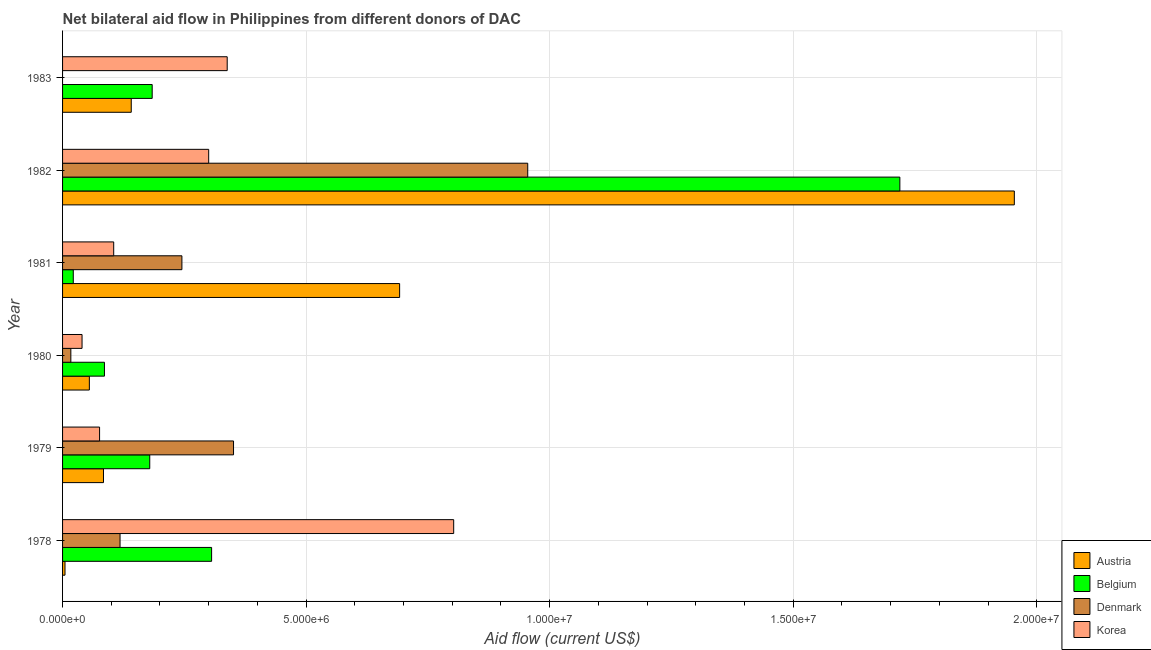How many different coloured bars are there?
Provide a succinct answer. 4. Are the number of bars per tick equal to the number of legend labels?
Offer a terse response. No. Are the number of bars on each tick of the Y-axis equal?
Provide a succinct answer. No. How many bars are there on the 1st tick from the bottom?
Your response must be concise. 4. What is the amount of aid given by korea in 1979?
Offer a terse response. 7.60e+05. Across all years, what is the maximum amount of aid given by austria?
Give a very brief answer. 1.95e+07. Across all years, what is the minimum amount of aid given by korea?
Offer a very short reply. 4.00e+05. In which year was the amount of aid given by austria maximum?
Provide a succinct answer. 1982. What is the total amount of aid given by austria in the graph?
Provide a short and direct response. 2.93e+07. What is the difference between the amount of aid given by belgium in 1978 and that in 1979?
Offer a very short reply. 1.27e+06. What is the difference between the amount of aid given by denmark in 1980 and the amount of aid given by korea in 1983?
Your answer should be compact. -3.21e+06. What is the average amount of aid given by denmark per year?
Your answer should be compact. 2.81e+06. In the year 1979, what is the difference between the amount of aid given by austria and amount of aid given by belgium?
Your answer should be very brief. -9.50e+05. In how many years, is the amount of aid given by denmark greater than 16000000 US$?
Give a very brief answer. 0. What is the ratio of the amount of aid given by korea in 1979 to that in 1980?
Offer a very short reply. 1.9. Is the amount of aid given by belgium in 1979 less than that in 1980?
Offer a terse response. No. Is the difference between the amount of aid given by belgium in 1978 and 1979 greater than the difference between the amount of aid given by denmark in 1978 and 1979?
Give a very brief answer. Yes. What is the difference between the highest and the second highest amount of aid given by belgium?
Provide a succinct answer. 1.41e+07. What is the difference between the highest and the lowest amount of aid given by belgium?
Provide a succinct answer. 1.70e+07. Are all the bars in the graph horizontal?
Provide a succinct answer. Yes. What is the difference between two consecutive major ticks on the X-axis?
Give a very brief answer. 5.00e+06. Are the values on the major ticks of X-axis written in scientific E-notation?
Provide a succinct answer. Yes. Where does the legend appear in the graph?
Give a very brief answer. Bottom right. How many legend labels are there?
Make the answer very short. 4. What is the title of the graph?
Offer a terse response. Net bilateral aid flow in Philippines from different donors of DAC. What is the label or title of the X-axis?
Your answer should be very brief. Aid flow (current US$). What is the Aid flow (current US$) of Belgium in 1978?
Provide a short and direct response. 3.06e+06. What is the Aid flow (current US$) in Denmark in 1978?
Provide a short and direct response. 1.18e+06. What is the Aid flow (current US$) of Korea in 1978?
Provide a short and direct response. 8.03e+06. What is the Aid flow (current US$) of Austria in 1979?
Your response must be concise. 8.40e+05. What is the Aid flow (current US$) in Belgium in 1979?
Offer a terse response. 1.79e+06. What is the Aid flow (current US$) of Denmark in 1979?
Provide a succinct answer. 3.51e+06. What is the Aid flow (current US$) of Korea in 1979?
Your response must be concise. 7.60e+05. What is the Aid flow (current US$) of Belgium in 1980?
Make the answer very short. 8.60e+05. What is the Aid flow (current US$) of Austria in 1981?
Provide a succinct answer. 6.92e+06. What is the Aid flow (current US$) in Belgium in 1981?
Your response must be concise. 2.20e+05. What is the Aid flow (current US$) of Denmark in 1981?
Provide a short and direct response. 2.45e+06. What is the Aid flow (current US$) in Korea in 1981?
Offer a very short reply. 1.05e+06. What is the Aid flow (current US$) of Austria in 1982?
Provide a short and direct response. 1.95e+07. What is the Aid flow (current US$) in Belgium in 1982?
Offer a very short reply. 1.72e+07. What is the Aid flow (current US$) in Denmark in 1982?
Provide a succinct answer. 9.55e+06. What is the Aid flow (current US$) of Austria in 1983?
Your answer should be very brief. 1.41e+06. What is the Aid flow (current US$) of Belgium in 1983?
Your answer should be compact. 1.84e+06. What is the Aid flow (current US$) of Korea in 1983?
Your answer should be compact. 3.38e+06. Across all years, what is the maximum Aid flow (current US$) in Austria?
Your response must be concise. 1.95e+07. Across all years, what is the maximum Aid flow (current US$) of Belgium?
Give a very brief answer. 1.72e+07. Across all years, what is the maximum Aid flow (current US$) in Denmark?
Make the answer very short. 9.55e+06. Across all years, what is the maximum Aid flow (current US$) of Korea?
Give a very brief answer. 8.03e+06. Across all years, what is the minimum Aid flow (current US$) in Austria?
Make the answer very short. 5.00e+04. Across all years, what is the minimum Aid flow (current US$) of Korea?
Your answer should be compact. 4.00e+05. What is the total Aid flow (current US$) of Austria in the graph?
Provide a short and direct response. 2.93e+07. What is the total Aid flow (current US$) of Belgium in the graph?
Keep it short and to the point. 2.50e+07. What is the total Aid flow (current US$) of Denmark in the graph?
Keep it short and to the point. 1.69e+07. What is the total Aid flow (current US$) in Korea in the graph?
Keep it short and to the point. 1.66e+07. What is the difference between the Aid flow (current US$) in Austria in 1978 and that in 1979?
Provide a succinct answer. -7.90e+05. What is the difference between the Aid flow (current US$) of Belgium in 1978 and that in 1979?
Ensure brevity in your answer.  1.27e+06. What is the difference between the Aid flow (current US$) in Denmark in 1978 and that in 1979?
Provide a short and direct response. -2.33e+06. What is the difference between the Aid flow (current US$) of Korea in 1978 and that in 1979?
Provide a short and direct response. 7.27e+06. What is the difference between the Aid flow (current US$) of Austria in 1978 and that in 1980?
Offer a terse response. -5.00e+05. What is the difference between the Aid flow (current US$) in Belgium in 1978 and that in 1980?
Offer a very short reply. 2.20e+06. What is the difference between the Aid flow (current US$) of Denmark in 1978 and that in 1980?
Keep it short and to the point. 1.01e+06. What is the difference between the Aid flow (current US$) in Korea in 1978 and that in 1980?
Provide a short and direct response. 7.63e+06. What is the difference between the Aid flow (current US$) in Austria in 1978 and that in 1981?
Your response must be concise. -6.87e+06. What is the difference between the Aid flow (current US$) of Belgium in 1978 and that in 1981?
Your response must be concise. 2.84e+06. What is the difference between the Aid flow (current US$) of Denmark in 1978 and that in 1981?
Offer a very short reply. -1.27e+06. What is the difference between the Aid flow (current US$) in Korea in 1978 and that in 1981?
Keep it short and to the point. 6.98e+06. What is the difference between the Aid flow (current US$) of Austria in 1978 and that in 1982?
Make the answer very short. -1.95e+07. What is the difference between the Aid flow (current US$) of Belgium in 1978 and that in 1982?
Give a very brief answer. -1.41e+07. What is the difference between the Aid flow (current US$) of Denmark in 1978 and that in 1982?
Offer a very short reply. -8.37e+06. What is the difference between the Aid flow (current US$) in Korea in 1978 and that in 1982?
Ensure brevity in your answer.  5.03e+06. What is the difference between the Aid flow (current US$) in Austria in 1978 and that in 1983?
Your answer should be very brief. -1.36e+06. What is the difference between the Aid flow (current US$) of Belgium in 1978 and that in 1983?
Ensure brevity in your answer.  1.22e+06. What is the difference between the Aid flow (current US$) in Korea in 1978 and that in 1983?
Offer a very short reply. 4.65e+06. What is the difference between the Aid flow (current US$) in Austria in 1979 and that in 1980?
Offer a terse response. 2.90e+05. What is the difference between the Aid flow (current US$) of Belgium in 1979 and that in 1980?
Offer a terse response. 9.30e+05. What is the difference between the Aid flow (current US$) in Denmark in 1979 and that in 1980?
Keep it short and to the point. 3.34e+06. What is the difference between the Aid flow (current US$) in Korea in 1979 and that in 1980?
Your answer should be compact. 3.60e+05. What is the difference between the Aid flow (current US$) of Austria in 1979 and that in 1981?
Your answer should be very brief. -6.08e+06. What is the difference between the Aid flow (current US$) in Belgium in 1979 and that in 1981?
Offer a very short reply. 1.57e+06. What is the difference between the Aid flow (current US$) of Denmark in 1979 and that in 1981?
Keep it short and to the point. 1.06e+06. What is the difference between the Aid flow (current US$) in Korea in 1979 and that in 1981?
Ensure brevity in your answer.  -2.90e+05. What is the difference between the Aid flow (current US$) of Austria in 1979 and that in 1982?
Offer a terse response. -1.87e+07. What is the difference between the Aid flow (current US$) in Belgium in 1979 and that in 1982?
Make the answer very short. -1.54e+07. What is the difference between the Aid flow (current US$) of Denmark in 1979 and that in 1982?
Offer a terse response. -6.04e+06. What is the difference between the Aid flow (current US$) in Korea in 1979 and that in 1982?
Offer a terse response. -2.24e+06. What is the difference between the Aid flow (current US$) in Austria in 1979 and that in 1983?
Your answer should be very brief. -5.70e+05. What is the difference between the Aid flow (current US$) in Belgium in 1979 and that in 1983?
Your response must be concise. -5.00e+04. What is the difference between the Aid flow (current US$) in Korea in 1979 and that in 1983?
Give a very brief answer. -2.62e+06. What is the difference between the Aid flow (current US$) in Austria in 1980 and that in 1981?
Your answer should be very brief. -6.37e+06. What is the difference between the Aid flow (current US$) in Belgium in 1980 and that in 1981?
Offer a terse response. 6.40e+05. What is the difference between the Aid flow (current US$) in Denmark in 1980 and that in 1981?
Keep it short and to the point. -2.28e+06. What is the difference between the Aid flow (current US$) in Korea in 1980 and that in 1981?
Provide a short and direct response. -6.50e+05. What is the difference between the Aid flow (current US$) in Austria in 1980 and that in 1982?
Provide a succinct answer. -1.90e+07. What is the difference between the Aid flow (current US$) in Belgium in 1980 and that in 1982?
Ensure brevity in your answer.  -1.63e+07. What is the difference between the Aid flow (current US$) of Denmark in 1980 and that in 1982?
Ensure brevity in your answer.  -9.38e+06. What is the difference between the Aid flow (current US$) of Korea in 1980 and that in 1982?
Your answer should be very brief. -2.60e+06. What is the difference between the Aid flow (current US$) of Austria in 1980 and that in 1983?
Your answer should be compact. -8.60e+05. What is the difference between the Aid flow (current US$) of Belgium in 1980 and that in 1983?
Offer a very short reply. -9.80e+05. What is the difference between the Aid flow (current US$) in Korea in 1980 and that in 1983?
Your response must be concise. -2.98e+06. What is the difference between the Aid flow (current US$) of Austria in 1981 and that in 1982?
Your response must be concise. -1.26e+07. What is the difference between the Aid flow (current US$) in Belgium in 1981 and that in 1982?
Your answer should be very brief. -1.70e+07. What is the difference between the Aid flow (current US$) in Denmark in 1981 and that in 1982?
Keep it short and to the point. -7.10e+06. What is the difference between the Aid flow (current US$) of Korea in 1981 and that in 1982?
Provide a short and direct response. -1.95e+06. What is the difference between the Aid flow (current US$) of Austria in 1981 and that in 1983?
Provide a short and direct response. 5.51e+06. What is the difference between the Aid flow (current US$) in Belgium in 1981 and that in 1983?
Ensure brevity in your answer.  -1.62e+06. What is the difference between the Aid flow (current US$) of Korea in 1981 and that in 1983?
Offer a very short reply. -2.33e+06. What is the difference between the Aid flow (current US$) in Austria in 1982 and that in 1983?
Offer a very short reply. 1.81e+07. What is the difference between the Aid flow (current US$) in Belgium in 1982 and that in 1983?
Make the answer very short. 1.54e+07. What is the difference between the Aid flow (current US$) in Korea in 1982 and that in 1983?
Give a very brief answer. -3.80e+05. What is the difference between the Aid flow (current US$) in Austria in 1978 and the Aid flow (current US$) in Belgium in 1979?
Ensure brevity in your answer.  -1.74e+06. What is the difference between the Aid flow (current US$) of Austria in 1978 and the Aid flow (current US$) of Denmark in 1979?
Your answer should be compact. -3.46e+06. What is the difference between the Aid flow (current US$) of Austria in 1978 and the Aid flow (current US$) of Korea in 1979?
Keep it short and to the point. -7.10e+05. What is the difference between the Aid flow (current US$) in Belgium in 1978 and the Aid flow (current US$) in Denmark in 1979?
Keep it short and to the point. -4.50e+05. What is the difference between the Aid flow (current US$) in Belgium in 1978 and the Aid flow (current US$) in Korea in 1979?
Your answer should be compact. 2.30e+06. What is the difference between the Aid flow (current US$) in Denmark in 1978 and the Aid flow (current US$) in Korea in 1979?
Keep it short and to the point. 4.20e+05. What is the difference between the Aid flow (current US$) in Austria in 1978 and the Aid flow (current US$) in Belgium in 1980?
Provide a succinct answer. -8.10e+05. What is the difference between the Aid flow (current US$) in Austria in 1978 and the Aid flow (current US$) in Denmark in 1980?
Ensure brevity in your answer.  -1.20e+05. What is the difference between the Aid flow (current US$) of Austria in 1978 and the Aid flow (current US$) of Korea in 1980?
Give a very brief answer. -3.50e+05. What is the difference between the Aid flow (current US$) in Belgium in 1978 and the Aid flow (current US$) in Denmark in 1980?
Provide a short and direct response. 2.89e+06. What is the difference between the Aid flow (current US$) in Belgium in 1978 and the Aid flow (current US$) in Korea in 1980?
Keep it short and to the point. 2.66e+06. What is the difference between the Aid flow (current US$) of Denmark in 1978 and the Aid flow (current US$) of Korea in 1980?
Provide a short and direct response. 7.80e+05. What is the difference between the Aid flow (current US$) in Austria in 1978 and the Aid flow (current US$) in Denmark in 1981?
Offer a very short reply. -2.40e+06. What is the difference between the Aid flow (current US$) in Austria in 1978 and the Aid flow (current US$) in Korea in 1981?
Offer a very short reply. -1.00e+06. What is the difference between the Aid flow (current US$) in Belgium in 1978 and the Aid flow (current US$) in Korea in 1981?
Offer a terse response. 2.01e+06. What is the difference between the Aid flow (current US$) in Austria in 1978 and the Aid flow (current US$) in Belgium in 1982?
Your answer should be compact. -1.71e+07. What is the difference between the Aid flow (current US$) in Austria in 1978 and the Aid flow (current US$) in Denmark in 1982?
Provide a succinct answer. -9.50e+06. What is the difference between the Aid flow (current US$) of Austria in 1978 and the Aid flow (current US$) of Korea in 1982?
Ensure brevity in your answer.  -2.95e+06. What is the difference between the Aid flow (current US$) in Belgium in 1978 and the Aid flow (current US$) in Denmark in 1982?
Offer a terse response. -6.49e+06. What is the difference between the Aid flow (current US$) of Denmark in 1978 and the Aid flow (current US$) of Korea in 1982?
Provide a short and direct response. -1.82e+06. What is the difference between the Aid flow (current US$) of Austria in 1978 and the Aid flow (current US$) of Belgium in 1983?
Your answer should be compact. -1.79e+06. What is the difference between the Aid flow (current US$) of Austria in 1978 and the Aid flow (current US$) of Korea in 1983?
Ensure brevity in your answer.  -3.33e+06. What is the difference between the Aid flow (current US$) of Belgium in 1978 and the Aid flow (current US$) of Korea in 1983?
Ensure brevity in your answer.  -3.20e+05. What is the difference between the Aid flow (current US$) of Denmark in 1978 and the Aid flow (current US$) of Korea in 1983?
Your answer should be very brief. -2.20e+06. What is the difference between the Aid flow (current US$) in Austria in 1979 and the Aid flow (current US$) in Denmark in 1980?
Your answer should be compact. 6.70e+05. What is the difference between the Aid flow (current US$) of Austria in 1979 and the Aid flow (current US$) of Korea in 1980?
Keep it short and to the point. 4.40e+05. What is the difference between the Aid flow (current US$) of Belgium in 1979 and the Aid flow (current US$) of Denmark in 1980?
Your answer should be very brief. 1.62e+06. What is the difference between the Aid flow (current US$) of Belgium in 1979 and the Aid flow (current US$) of Korea in 1980?
Keep it short and to the point. 1.39e+06. What is the difference between the Aid flow (current US$) of Denmark in 1979 and the Aid flow (current US$) of Korea in 1980?
Offer a terse response. 3.11e+06. What is the difference between the Aid flow (current US$) in Austria in 1979 and the Aid flow (current US$) in Belgium in 1981?
Provide a short and direct response. 6.20e+05. What is the difference between the Aid flow (current US$) of Austria in 1979 and the Aid flow (current US$) of Denmark in 1981?
Provide a succinct answer. -1.61e+06. What is the difference between the Aid flow (current US$) in Austria in 1979 and the Aid flow (current US$) in Korea in 1981?
Keep it short and to the point. -2.10e+05. What is the difference between the Aid flow (current US$) in Belgium in 1979 and the Aid flow (current US$) in Denmark in 1981?
Keep it short and to the point. -6.60e+05. What is the difference between the Aid flow (current US$) of Belgium in 1979 and the Aid flow (current US$) of Korea in 1981?
Offer a terse response. 7.40e+05. What is the difference between the Aid flow (current US$) in Denmark in 1979 and the Aid flow (current US$) in Korea in 1981?
Your response must be concise. 2.46e+06. What is the difference between the Aid flow (current US$) of Austria in 1979 and the Aid flow (current US$) of Belgium in 1982?
Provide a short and direct response. -1.64e+07. What is the difference between the Aid flow (current US$) in Austria in 1979 and the Aid flow (current US$) in Denmark in 1982?
Offer a very short reply. -8.71e+06. What is the difference between the Aid flow (current US$) of Austria in 1979 and the Aid flow (current US$) of Korea in 1982?
Keep it short and to the point. -2.16e+06. What is the difference between the Aid flow (current US$) of Belgium in 1979 and the Aid flow (current US$) of Denmark in 1982?
Make the answer very short. -7.76e+06. What is the difference between the Aid flow (current US$) in Belgium in 1979 and the Aid flow (current US$) in Korea in 1982?
Ensure brevity in your answer.  -1.21e+06. What is the difference between the Aid flow (current US$) of Denmark in 1979 and the Aid flow (current US$) of Korea in 1982?
Make the answer very short. 5.10e+05. What is the difference between the Aid flow (current US$) of Austria in 1979 and the Aid flow (current US$) of Korea in 1983?
Offer a terse response. -2.54e+06. What is the difference between the Aid flow (current US$) of Belgium in 1979 and the Aid flow (current US$) of Korea in 1983?
Provide a short and direct response. -1.59e+06. What is the difference between the Aid flow (current US$) in Austria in 1980 and the Aid flow (current US$) in Belgium in 1981?
Provide a succinct answer. 3.30e+05. What is the difference between the Aid flow (current US$) of Austria in 1980 and the Aid flow (current US$) of Denmark in 1981?
Provide a short and direct response. -1.90e+06. What is the difference between the Aid flow (current US$) of Austria in 1980 and the Aid flow (current US$) of Korea in 1981?
Ensure brevity in your answer.  -5.00e+05. What is the difference between the Aid flow (current US$) in Belgium in 1980 and the Aid flow (current US$) in Denmark in 1981?
Your answer should be compact. -1.59e+06. What is the difference between the Aid flow (current US$) in Belgium in 1980 and the Aid flow (current US$) in Korea in 1981?
Offer a terse response. -1.90e+05. What is the difference between the Aid flow (current US$) of Denmark in 1980 and the Aid flow (current US$) of Korea in 1981?
Make the answer very short. -8.80e+05. What is the difference between the Aid flow (current US$) of Austria in 1980 and the Aid flow (current US$) of Belgium in 1982?
Give a very brief answer. -1.66e+07. What is the difference between the Aid flow (current US$) in Austria in 1980 and the Aid flow (current US$) in Denmark in 1982?
Offer a very short reply. -9.00e+06. What is the difference between the Aid flow (current US$) of Austria in 1980 and the Aid flow (current US$) of Korea in 1982?
Your answer should be compact. -2.45e+06. What is the difference between the Aid flow (current US$) in Belgium in 1980 and the Aid flow (current US$) in Denmark in 1982?
Your answer should be compact. -8.69e+06. What is the difference between the Aid flow (current US$) of Belgium in 1980 and the Aid flow (current US$) of Korea in 1982?
Your response must be concise. -2.14e+06. What is the difference between the Aid flow (current US$) in Denmark in 1980 and the Aid flow (current US$) in Korea in 1982?
Keep it short and to the point. -2.83e+06. What is the difference between the Aid flow (current US$) of Austria in 1980 and the Aid flow (current US$) of Belgium in 1983?
Provide a short and direct response. -1.29e+06. What is the difference between the Aid flow (current US$) in Austria in 1980 and the Aid flow (current US$) in Korea in 1983?
Your answer should be compact. -2.83e+06. What is the difference between the Aid flow (current US$) in Belgium in 1980 and the Aid flow (current US$) in Korea in 1983?
Provide a succinct answer. -2.52e+06. What is the difference between the Aid flow (current US$) in Denmark in 1980 and the Aid flow (current US$) in Korea in 1983?
Ensure brevity in your answer.  -3.21e+06. What is the difference between the Aid flow (current US$) in Austria in 1981 and the Aid flow (current US$) in Belgium in 1982?
Offer a terse response. -1.03e+07. What is the difference between the Aid flow (current US$) of Austria in 1981 and the Aid flow (current US$) of Denmark in 1982?
Offer a very short reply. -2.63e+06. What is the difference between the Aid flow (current US$) in Austria in 1981 and the Aid flow (current US$) in Korea in 1982?
Offer a terse response. 3.92e+06. What is the difference between the Aid flow (current US$) of Belgium in 1981 and the Aid flow (current US$) of Denmark in 1982?
Provide a succinct answer. -9.33e+06. What is the difference between the Aid flow (current US$) in Belgium in 1981 and the Aid flow (current US$) in Korea in 1982?
Give a very brief answer. -2.78e+06. What is the difference between the Aid flow (current US$) of Denmark in 1981 and the Aid flow (current US$) of Korea in 1982?
Offer a terse response. -5.50e+05. What is the difference between the Aid flow (current US$) of Austria in 1981 and the Aid flow (current US$) of Belgium in 1983?
Keep it short and to the point. 5.08e+06. What is the difference between the Aid flow (current US$) of Austria in 1981 and the Aid flow (current US$) of Korea in 1983?
Give a very brief answer. 3.54e+06. What is the difference between the Aid flow (current US$) in Belgium in 1981 and the Aid flow (current US$) in Korea in 1983?
Provide a short and direct response. -3.16e+06. What is the difference between the Aid flow (current US$) of Denmark in 1981 and the Aid flow (current US$) of Korea in 1983?
Ensure brevity in your answer.  -9.30e+05. What is the difference between the Aid flow (current US$) of Austria in 1982 and the Aid flow (current US$) of Belgium in 1983?
Your answer should be very brief. 1.77e+07. What is the difference between the Aid flow (current US$) in Austria in 1982 and the Aid flow (current US$) in Korea in 1983?
Offer a terse response. 1.62e+07. What is the difference between the Aid flow (current US$) in Belgium in 1982 and the Aid flow (current US$) in Korea in 1983?
Your response must be concise. 1.38e+07. What is the difference between the Aid flow (current US$) of Denmark in 1982 and the Aid flow (current US$) of Korea in 1983?
Keep it short and to the point. 6.17e+06. What is the average Aid flow (current US$) in Austria per year?
Provide a succinct answer. 4.88e+06. What is the average Aid flow (current US$) in Belgium per year?
Your response must be concise. 4.16e+06. What is the average Aid flow (current US$) of Denmark per year?
Your response must be concise. 2.81e+06. What is the average Aid flow (current US$) in Korea per year?
Provide a succinct answer. 2.77e+06. In the year 1978, what is the difference between the Aid flow (current US$) of Austria and Aid flow (current US$) of Belgium?
Provide a short and direct response. -3.01e+06. In the year 1978, what is the difference between the Aid flow (current US$) of Austria and Aid flow (current US$) of Denmark?
Ensure brevity in your answer.  -1.13e+06. In the year 1978, what is the difference between the Aid flow (current US$) of Austria and Aid flow (current US$) of Korea?
Provide a short and direct response. -7.98e+06. In the year 1978, what is the difference between the Aid flow (current US$) in Belgium and Aid flow (current US$) in Denmark?
Keep it short and to the point. 1.88e+06. In the year 1978, what is the difference between the Aid flow (current US$) of Belgium and Aid flow (current US$) of Korea?
Make the answer very short. -4.97e+06. In the year 1978, what is the difference between the Aid flow (current US$) of Denmark and Aid flow (current US$) of Korea?
Offer a terse response. -6.85e+06. In the year 1979, what is the difference between the Aid flow (current US$) of Austria and Aid flow (current US$) of Belgium?
Offer a terse response. -9.50e+05. In the year 1979, what is the difference between the Aid flow (current US$) of Austria and Aid flow (current US$) of Denmark?
Your answer should be very brief. -2.67e+06. In the year 1979, what is the difference between the Aid flow (current US$) of Belgium and Aid flow (current US$) of Denmark?
Keep it short and to the point. -1.72e+06. In the year 1979, what is the difference between the Aid flow (current US$) of Belgium and Aid flow (current US$) of Korea?
Keep it short and to the point. 1.03e+06. In the year 1979, what is the difference between the Aid flow (current US$) in Denmark and Aid flow (current US$) in Korea?
Make the answer very short. 2.75e+06. In the year 1980, what is the difference between the Aid flow (current US$) of Austria and Aid flow (current US$) of Belgium?
Give a very brief answer. -3.10e+05. In the year 1980, what is the difference between the Aid flow (current US$) of Austria and Aid flow (current US$) of Korea?
Your answer should be compact. 1.50e+05. In the year 1980, what is the difference between the Aid flow (current US$) in Belgium and Aid flow (current US$) in Denmark?
Give a very brief answer. 6.90e+05. In the year 1980, what is the difference between the Aid flow (current US$) in Belgium and Aid flow (current US$) in Korea?
Provide a short and direct response. 4.60e+05. In the year 1981, what is the difference between the Aid flow (current US$) in Austria and Aid flow (current US$) in Belgium?
Give a very brief answer. 6.70e+06. In the year 1981, what is the difference between the Aid flow (current US$) in Austria and Aid flow (current US$) in Denmark?
Your answer should be compact. 4.47e+06. In the year 1981, what is the difference between the Aid flow (current US$) in Austria and Aid flow (current US$) in Korea?
Ensure brevity in your answer.  5.87e+06. In the year 1981, what is the difference between the Aid flow (current US$) in Belgium and Aid flow (current US$) in Denmark?
Your response must be concise. -2.23e+06. In the year 1981, what is the difference between the Aid flow (current US$) in Belgium and Aid flow (current US$) in Korea?
Provide a succinct answer. -8.30e+05. In the year 1981, what is the difference between the Aid flow (current US$) of Denmark and Aid flow (current US$) of Korea?
Your response must be concise. 1.40e+06. In the year 1982, what is the difference between the Aid flow (current US$) of Austria and Aid flow (current US$) of Belgium?
Offer a terse response. 2.35e+06. In the year 1982, what is the difference between the Aid flow (current US$) of Austria and Aid flow (current US$) of Denmark?
Provide a short and direct response. 9.99e+06. In the year 1982, what is the difference between the Aid flow (current US$) in Austria and Aid flow (current US$) in Korea?
Offer a terse response. 1.65e+07. In the year 1982, what is the difference between the Aid flow (current US$) in Belgium and Aid flow (current US$) in Denmark?
Your response must be concise. 7.64e+06. In the year 1982, what is the difference between the Aid flow (current US$) of Belgium and Aid flow (current US$) of Korea?
Give a very brief answer. 1.42e+07. In the year 1982, what is the difference between the Aid flow (current US$) in Denmark and Aid flow (current US$) in Korea?
Provide a short and direct response. 6.55e+06. In the year 1983, what is the difference between the Aid flow (current US$) in Austria and Aid flow (current US$) in Belgium?
Make the answer very short. -4.30e+05. In the year 1983, what is the difference between the Aid flow (current US$) of Austria and Aid flow (current US$) of Korea?
Provide a short and direct response. -1.97e+06. In the year 1983, what is the difference between the Aid flow (current US$) in Belgium and Aid flow (current US$) in Korea?
Offer a terse response. -1.54e+06. What is the ratio of the Aid flow (current US$) of Austria in 1978 to that in 1979?
Keep it short and to the point. 0.06. What is the ratio of the Aid flow (current US$) of Belgium in 1978 to that in 1979?
Keep it short and to the point. 1.71. What is the ratio of the Aid flow (current US$) in Denmark in 1978 to that in 1979?
Offer a very short reply. 0.34. What is the ratio of the Aid flow (current US$) of Korea in 1978 to that in 1979?
Make the answer very short. 10.57. What is the ratio of the Aid flow (current US$) of Austria in 1978 to that in 1980?
Keep it short and to the point. 0.09. What is the ratio of the Aid flow (current US$) of Belgium in 1978 to that in 1980?
Offer a very short reply. 3.56. What is the ratio of the Aid flow (current US$) in Denmark in 1978 to that in 1980?
Make the answer very short. 6.94. What is the ratio of the Aid flow (current US$) of Korea in 1978 to that in 1980?
Give a very brief answer. 20.07. What is the ratio of the Aid flow (current US$) in Austria in 1978 to that in 1981?
Keep it short and to the point. 0.01. What is the ratio of the Aid flow (current US$) of Belgium in 1978 to that in 1981?
Offer a very short reply. 13.91. What is the ratio of the Aid flow (current US$) in Denmark in 1978 to that in 1981?
Your answer should be compact. 0.48. What is the ratio of the Aid flow (current US$) in Korea in 1978 to that in 1981?
Offer a very short reply. 7.65. What is the ratio of the Aid flow (current US$) of Austria in 1978 to that in 1982?
Provide a short and direct response. 0. What is the ratio of the Aid flow (current US$) of Belgium in 1978 to that in 1982?
Offer a terse response. 0.18. What is the ratio of the Aid flow (current US$) in Denmark in 1978 to that in 1982?
Provide a short and direct response. 0.12. What is the ratio of the Aid flow (current US$) of Korea in 1978 to that in 1982?
Keep it short and to the point. 2.68. What is the ratio of the Aid flow (current US$) in Austria in 1978 to that in 1983?
Offer a terse response. 0.04. What is the ratio of the Aid flow (current US$) in Belgium in 1978 to that in 1983?
Your answer should be compact. 1.66. What is the ratio of the Aid flow (current US$) of Korea in 1978 to that in 1983?
Offer a very short reply. 2.38. What is the ratio of the Aid flow (current US$) of Austria in 1979 to that in 1980?
Your response must be concise. 1.53. What is the ratio of the Aid flow (current US$) in Belgium in 1979 to that in 1980?
Keep it short and to the point. 2.08. What is the ratio of the Aid flow (current US$) in Denmark in 1979 to that in 1980?
Provide a short and direct response. 20.65. What is the ratio of the Aid flow (current US$) of Austria in 1979 to that in 1981?
Offer a very short reply. 0.12. What is the ratio of the Aid flow (current US$) in Belgium in 1979 to that in 1981?
Offer a very short reply. 8.14. What is the ratio of the Aid flow (current US$) of Denmark in 1979 to that in 1981?
Offer a very short reply. 1.43. What is the ratio of the Aid flow (current US$) of Korea in 1979 to that in 1981?
Offer a very short reply. 0.72. What is the ratio of the Aid flow (current US$) in Austria in 1979 to that in 1982?
Provide a short and direct response. 0.04. What is the ratio of the Aid flow (current US$) of Belgium in 1979 to that in 1982?
Ensure brevity in your answer.  0.1. What is the ratio of the Aid flow (current US$) of Denmark in 1979 to that in 1982?
Make the answer very short. 0.37. What is the ratio of the Aid flow (current US$) of Korea in 1979 to that in 1982?
Provide a short and direct response. 0.25. What is the ratio of the Aid flow (current US$) in Austria in 1979 to that in 1983?
Your answer should be compact. 0.6. What is the ratio of the Aid flow (current US$) of Belgium in 1979 to that in 1983?
Offer a very short reply. 0.97. What is the ratio of the Aid flow (current US$) in Korea in 1979 to that in 1983?
Your answer should be compact. 0.22. What is the ratio of the Aid flow (current US$) of Austria in 1980 to that in 1981?
Offer a very short reply. 0.08. What is the ratio of the Aid flow (current US$) of Belgium in 1980 to that in 1981?
Keep it short and to the point. 3.91. What is the ratio of the Aid flow (current US$) of Denmark in 1980 to that in 1981?
Make the answer very short. 0.07. What is the ratio of the Aid flow (current US$) of Korea in 1980 to that in 1981?
Provide a succinct answer. 0.38. What is the ratio of the Aid flow (current US$) in Austria in 1980 to that in 1982?
Make the answer very short. 0.03. What is the ratio of the Aid flow (current US$) of Belgium in 1980 to that in 1982?
Your response must be concise. 0.05. What is the ratio of the Aid flow (current US$) of Denmark in 1980 to that in 1982?
Make the answer very short. 0.02. What is the ratio of the Aid flow (current US$) in Korea in 1980 to that in 1982?
Offer a very short reply. 0.13. What is the ratio of the Aid flow (current US$) in Austria in 1980 to that in 1983?
Your answer should be compact. 0.39. What is the ratio of the Aid flow (current US$) of Belgium in 1980 to that in 1983?
Your response must be concise. 0.47. What is the ratio of the Aid flow (current US$) of Korea in 1980 to that in 1983?
Provide a short and direct response. 0.12. What is the ratio of the Aid flow (current US$) of Austria in 1981 to that in 1982?
Make the answer very short. 0.35. What is the ratio of the Aid flow (current US$) in Belgium in 1981 to that in 1982?
Make the answer very short. 0.01. What is the ratio of the Aid flow (current US$) of Denmark in 1981 to that in 1982?
Your response must be concise. 0.26. What is the ratio of the Aid flow (current US$) in Austria in 1981 to that in 1983?
Offer a very short reply. 4.91. What is the ratio of the Aid flow (current US$) in Belgium in 1981 to that in 1983?
Offer a very short reply. 0.12. What is the ratio of the Aid flow (current US$) of Korea in 1981 to that in 1983?
Offer a very short reply. 0.31. What is the ratio of the Aid flow (current US$) of Austria in 1982 to that in 1983?
Your answer should be very brief. 13.86. What is the ratio of the Aid flow (current US$) of Belgium in 1982 to that in 1983?
Your response must be concise. 9.34. What is the ratio of the Aid flow (current US$) in Korea in 1982 to that in 1983?
Your response must be concise. 0.89. What is the difference between the highest and the second highest Aid flow (current US$) in Austria?
Ensure brevity in your answer.  1.26e+07. What is the difference between the highest and the second highest Aid flow (current US$) of Belgium?
Keep it short and to the point. 1.41e+07. What is the difference between the highest and the second highest Aid flow (current US$) in Denmark?
Make the answer very short. 6.04e+06. What is the difference between the highest and the second highest Aid flow (current US$) of Korea?
Provide a succinct answer. 4.65e+06. What is the difference between the highest and the lowest Aid flow (current US$) of Austria?
Your answer should be very brief. 1.95e+07. What is the difference between the highest and the lowest Aid flow (current US$) of Belgium?
Your response must be concise. 1.70e+07. What is the difference between the highest and the lowest Aid flow (current US$) of Denmark?
Keep it short and to the point. 9.55e+06. What is the difference between the highest and the lowest Aid flow (current US$) in Korea?
Offer a very short reply. 7.63e+06. 